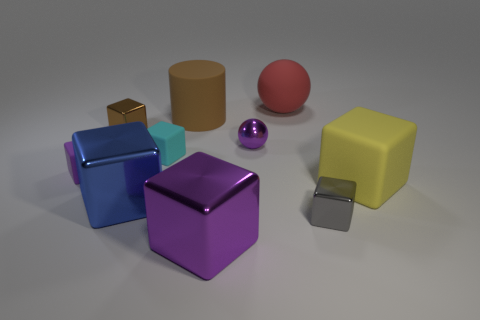There is a small purple shiny object that is right of the purple matte cube; what shape is it?
Provide a short and direct response. Sphere. Is the number of big brown rubber cylinders greater than the number of blue balls?
Offer a terse response. Yes. Does the object in front of the gray metal thing have the same color as the tiny metal sphere?
Offer a terse response. Yes. What number of objects are either metallic blocks in front of the small cyan matte thing or matte objects right of the tiny ball?
Offer a terse response. 5. What number of metal objects are on the right side of the large red matte ball and on the left side of the big brown cylinder?
Offer a terse response. 0. Are the yellow cube and the big red ball made of the same material?
Make the answer very short. Yes. The purple metallic object behind the metal cube right of the large object that is behind the large brown thing is what shape?
Your response must be concise. Sphere. What is the block that is both to the right of the brown block and left of the small cyan matte cube made of?
Keep it short and to the point. Metal. What is the color of the small metal block that is on the right side of the purple block that is in front of the purple block that is left of the cylinder?
Ensure brevity in your answer.  Gray. What number of gray things are cubes or big blocks?
Your answer should be very brief. 1. 